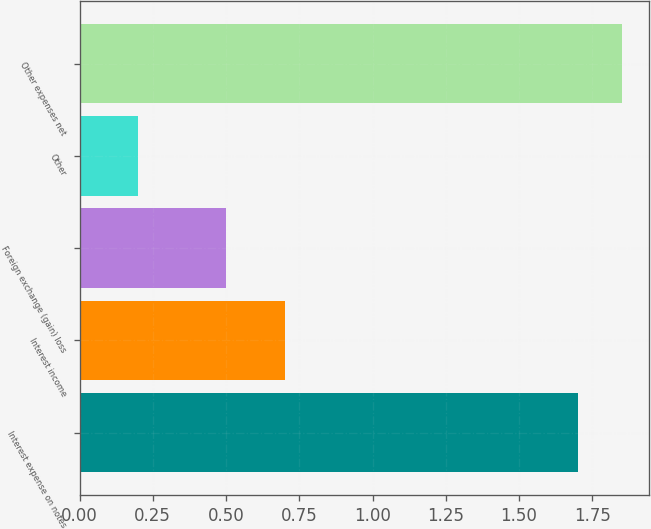Convert chart to OTSL. <chart><loc_0><loc_0><loc_500><loc_500><bar_chart><fcel>Interest expense on notes<fcel>Interest income<fcel>Foreign exchange (gain) loss<fcel>Other<fcel>Other expenses net<nl><fcel>1.7<fcel>0.7<fcel>0.5<fcel>0.2<fcel>1.85<nl></chart> 